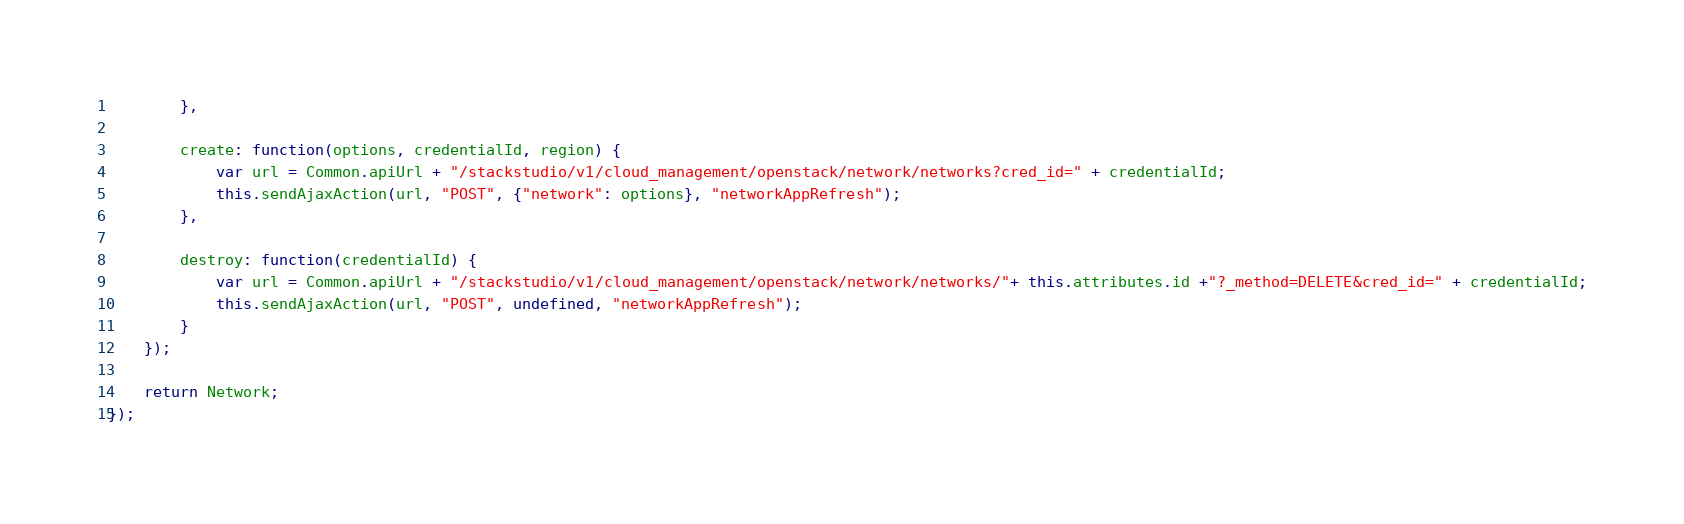<code> <loc_0><loc_0><loc_500><loc_500><_JavaScript_>        },

        create: function(options, credentialId, region) {
            var url = Common.apiUrl + "/stackstudio/v1/cloud_management/openstack/network/networks?cred_id=" + credentialId;
            this.sendAjaxAction(url, "POST", {"network": options}, "networkAppRefresh");
        },
        
        destroy: function(credentialId) {
            var url = Common.apiUrl + "/stackstudio/v1/cloud_management/openstack/network/networks/"+ this.attributes.id +"?_method=DELETE&cred_id=" + credentialId;
            this.sendAjaxAction(url, "POST", undefined, "networkAppRefresh");
        }
    });

    return Network;
});
</code> 